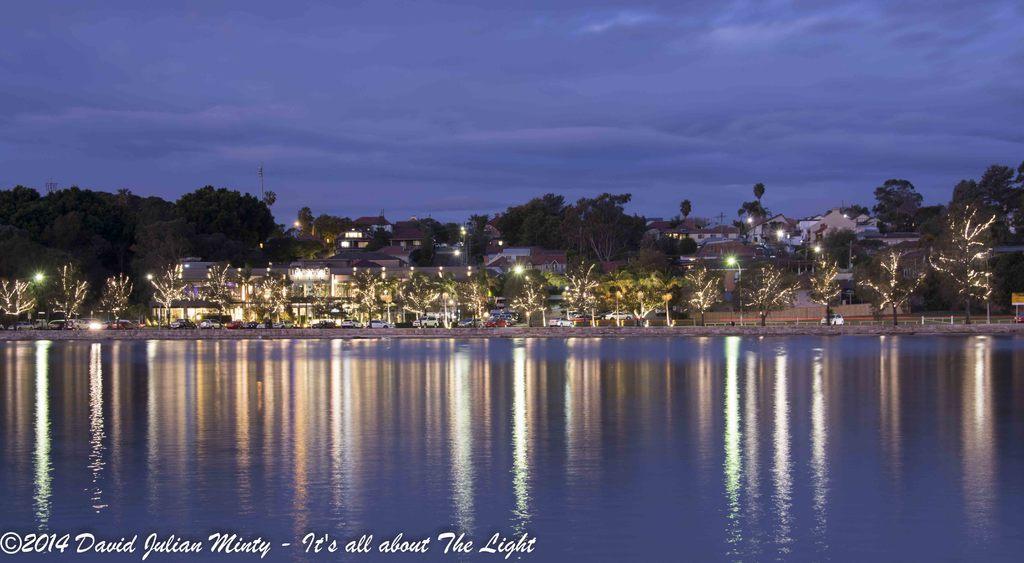In one or two sentences, can you explain what this image depicts? In this picture we can see water at the bottom, in the background there are some trees, buildings and lights, there is the sky at the top of the picture, at the left bottom we can see some text. 